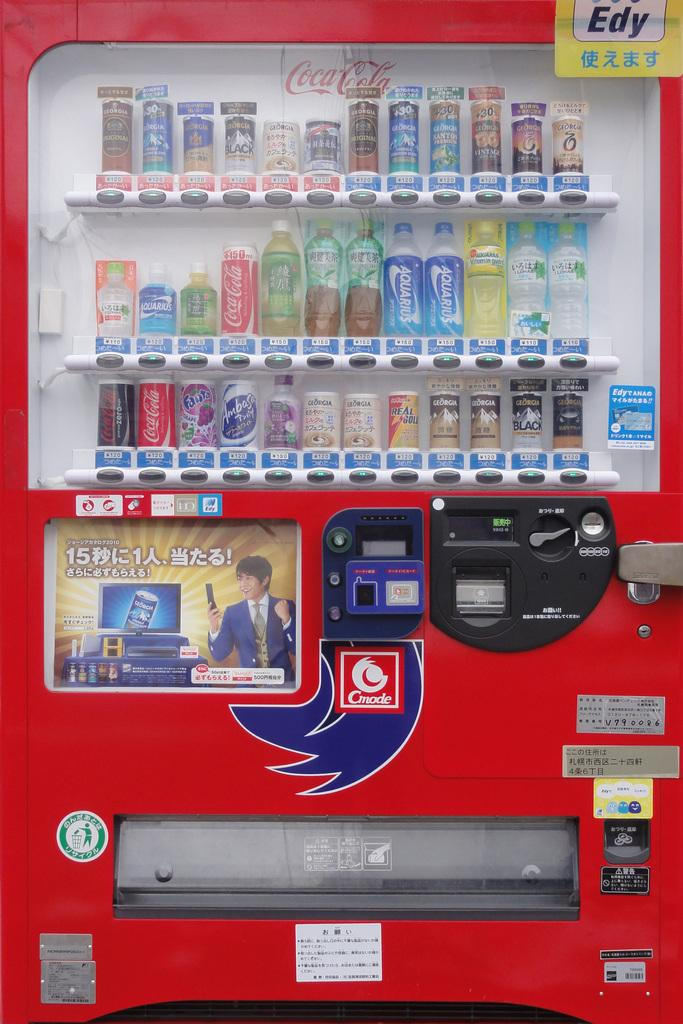<image>
Relay a brief, clear account of the picture shown. A vending machine features Coca Cola and a water brand called Aquarius 